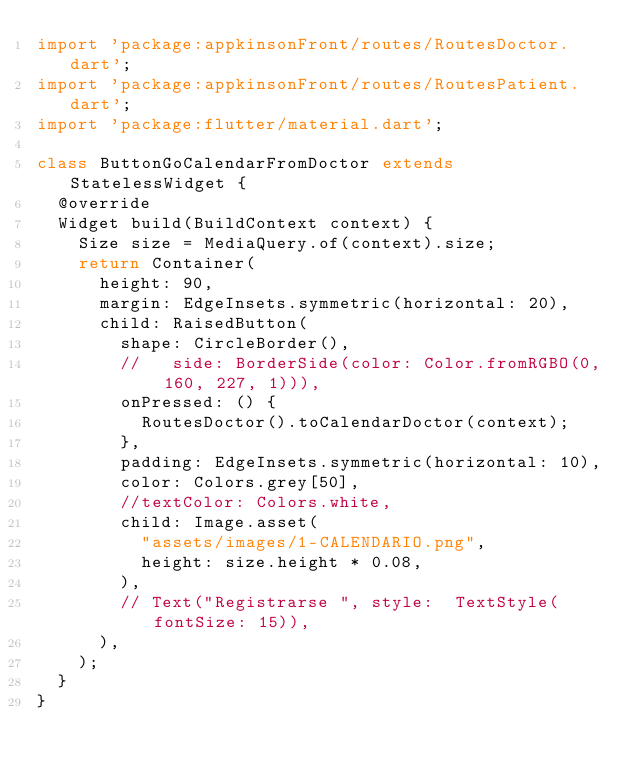Convert code to text. <code><loc_0><loc_0><loc_500><loc_500><_Dart_>import 'package:appkinsonFront/routes/RoutesDoctor.dart';
import 'package:appkinsonFront/routes/RoutesPatient.dart';
import 'package:flutter/material.dart';

class ButtonGoCalendarFromDoctor extends StatelessWidget {
  @override
  Widget build(BuildContext context) {
    Size size = MediaQuery.of(context).size;
    return Container(
      height: 90,
      margin: EdgeInsets.symmetric(horizontal: 20),
      child: RaisedButton(
        shape: CircleBorder(),
        //   side: BorderSide(color: Color.fromRGBO(0, 160, 227, 1))),
        onPressed: () {
          RoutesDoctor().toCalendarDoctor(context);
        },
        padding: EdgeInsets.symmetric(horizontal: 10),
        color: Colors.grey[50],
        //textColor: Colors.white,
        child: Image.asset(
          "assets/images/1-CALENDARIO.png",
          height: size.height * 0.08,
        ),
        // Text("Registrarse ", style:  TextStyle(fontSize: 15)),
      ),
    );
  }
}
</code> 